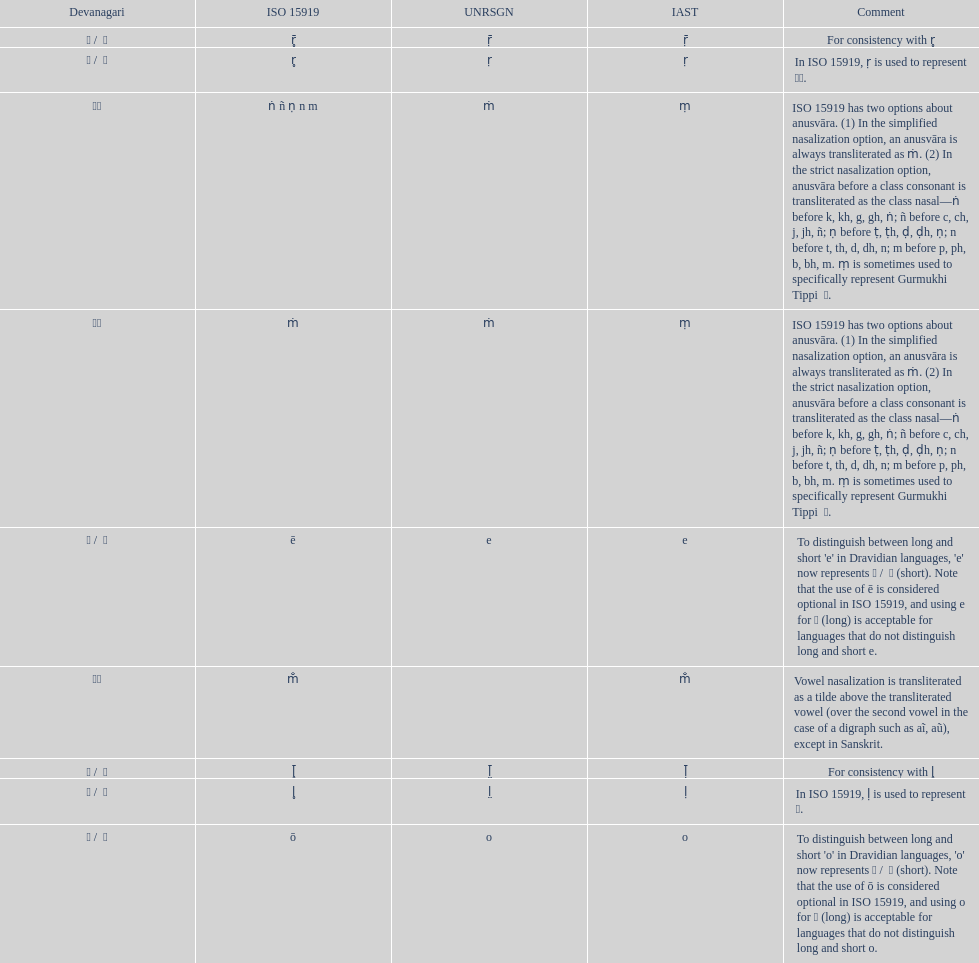This table shows the difference between how many transliterations? 3. 